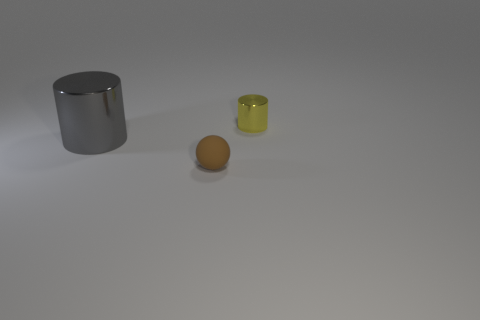What number of objects are behind the tiny ball and to the right of the gray cylinder?
Offer a very short reply. 1. How many other things are the same color as the small rubber object?
Provide a succinct answer. 0. What shape is the large gray thing that is in front of the small yellow cylinder?
Your answer should be compact. Cylinder. Do the big gray object and the tiny brown thing have the same material?
Your response must be concise. No. Are there any other things that are the same size as the gray metal cylinder?
Offer a terse response. No. There is a brown thing; what number of tiny yellow cylinders are behind it?
Offer a terse response. 1. What shape is the shiny thing to the left of the small sphere that is to the left of the small yellow metallic cylinder?
Provide a succinct answer. Cylinder. Is there any other thing that is the same shape as the matte thing?
Give a very brief answer. No. Are there more gray metallic objects that are behind the small brown rubber object than tiny brown metallic things?
Give a very brief answer. Yes. How many large cylinders are in front of the cylinder left of the small brown rubber ball?
Your response must be concise. 0. 